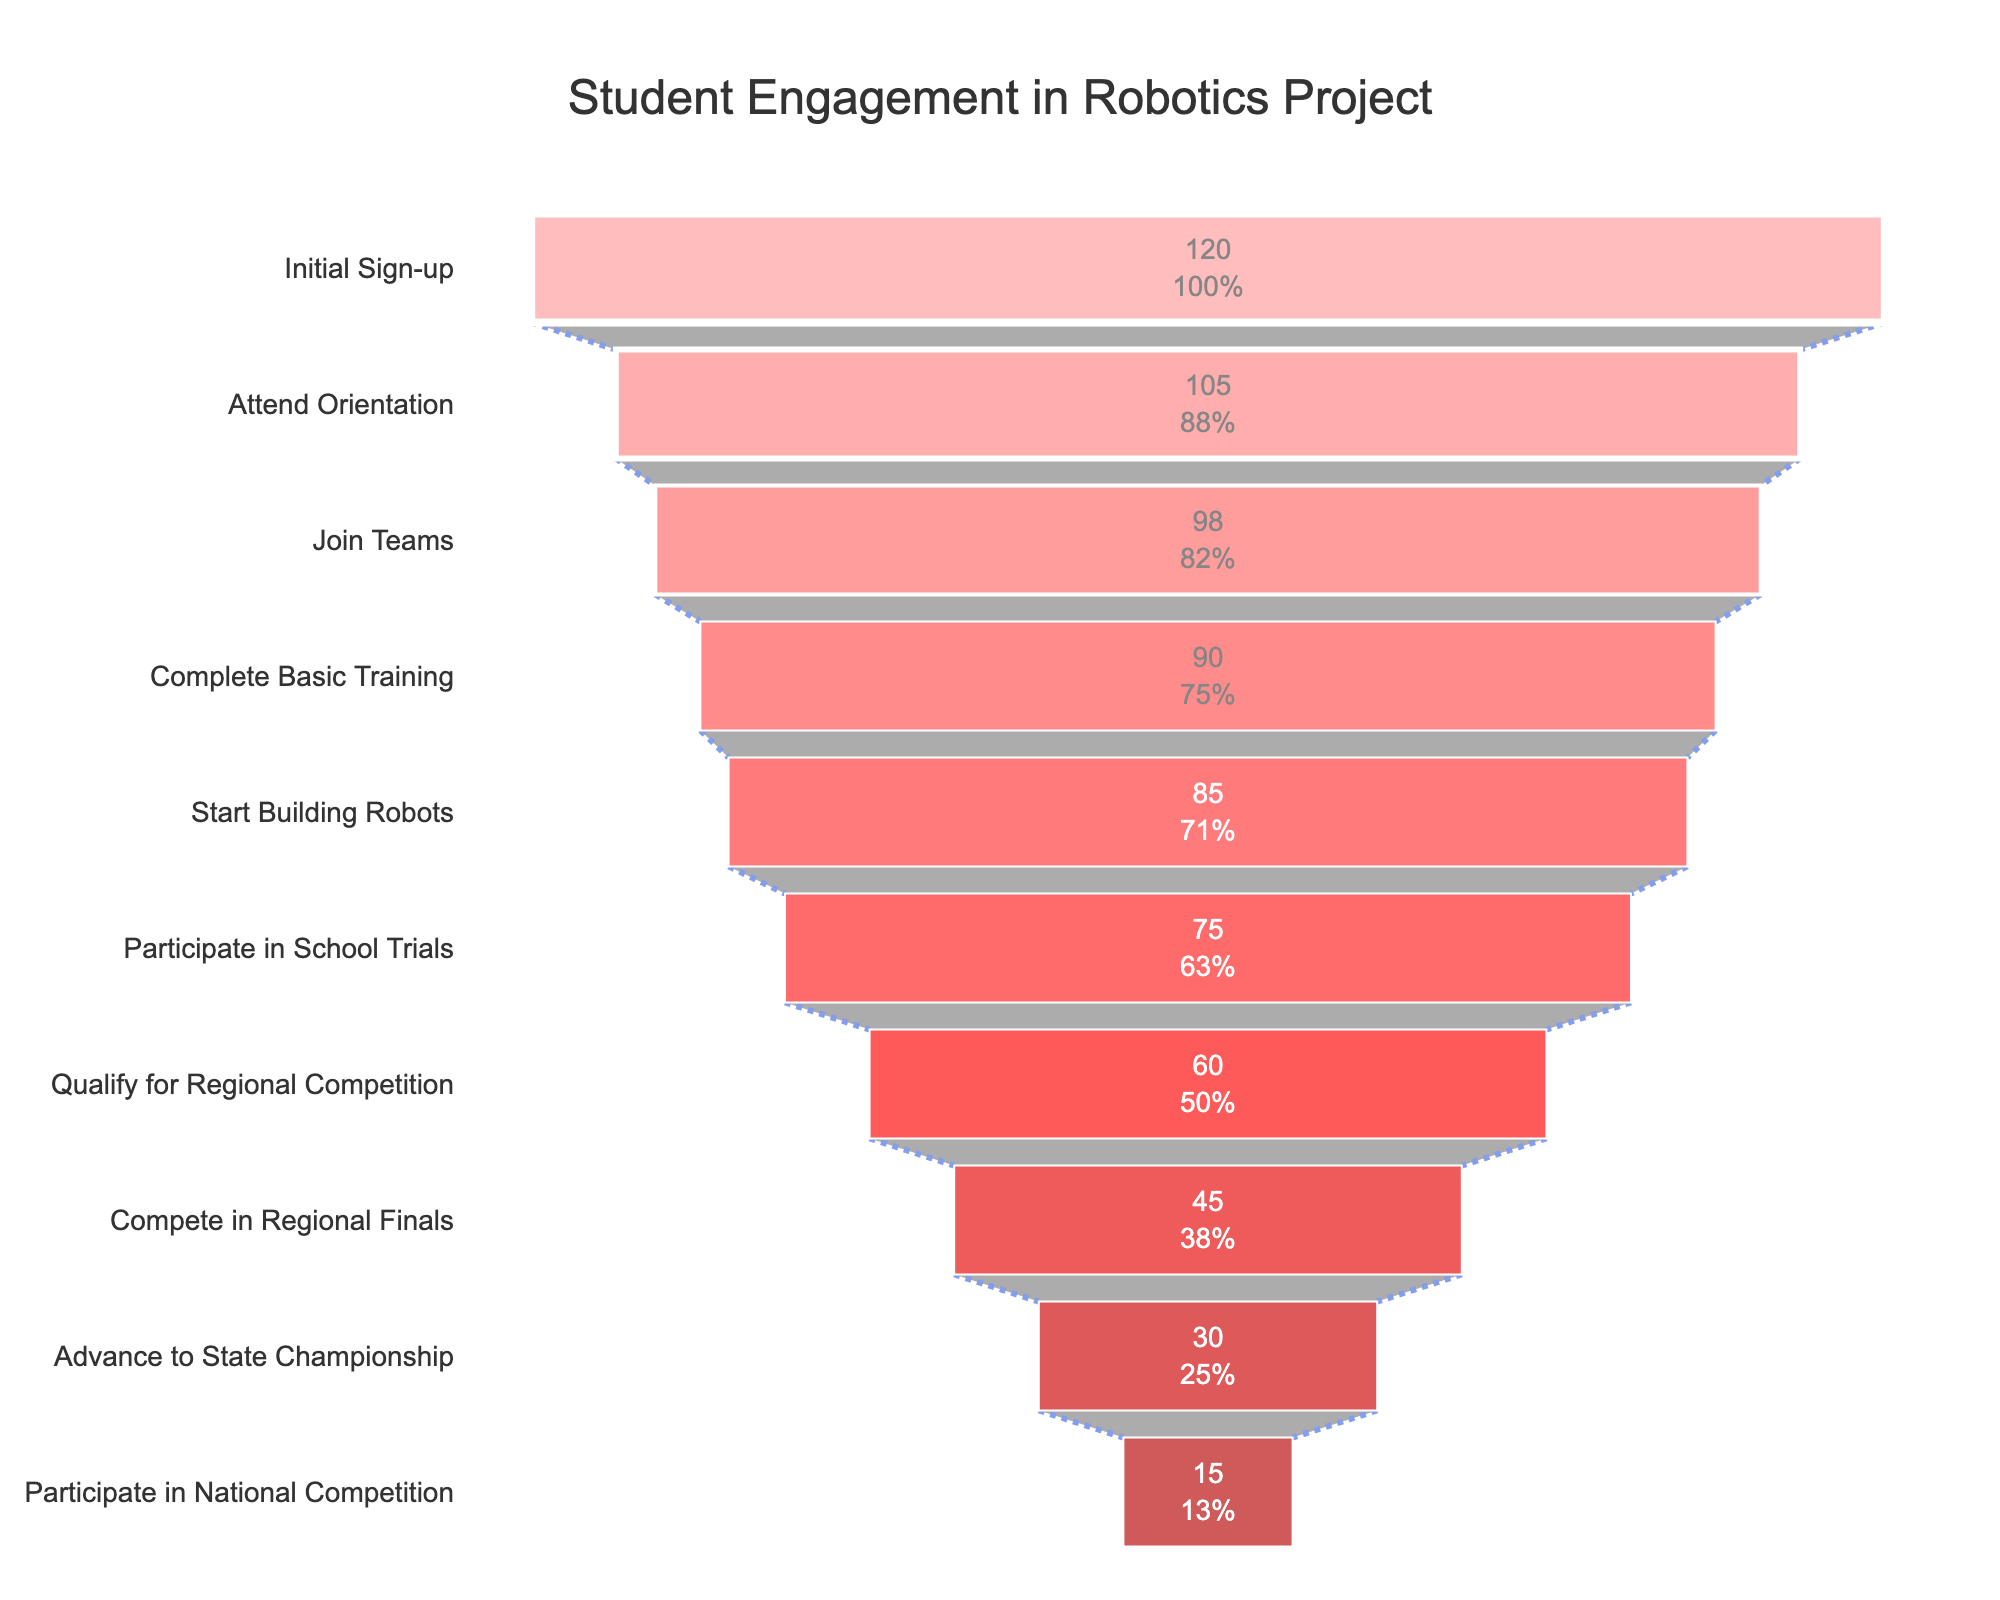What's the title of the chart? The title is displayed prominently at the top of the chart. Here, it reads "Student Engagement in Robotics Project."
Answer: Student Engagement in Robotics Project How many students participated in the school trials? Looking at the corresponding stage "Participate in School Trials" on the y-axis, the number next to it is 75.
Answer: 75 What's the percentage decrease in the number of students from the Initial Sign-up to the National Competition? The Initial Sign-up has 120 students, and the National Competition has 15 students. The percentage decrease is calculated as ((120 - 15) / 120) * 100. This gives a decrease of 87.5%.
Answer: 87.5% At which stage do you see the biggest drop in the number of students? The largest drop can be identified by scanning through the stages and finding the largest difference. From "Qualify for Regional Competition" (60) to "Compete in Regional Finals" (45) is the largest drop, with a decrease of 15 students.
Answer: Between Qualify for Regional Competition and Compete in Regional Finals, dropping by 15 students Is there any stage where more than 90% of the initial students are still participating? To check this, we need to see if any stage has more than 108 (which is 90% of 120) students. The "Automatic Telemetry Integration of Mainframe" stage has 105 students, so the answer is yes.
Answer: Yes, Attend Orientation stage How many students dropped out between the "Complete Basic Training" and "Start Building Robots" stages? The number of students in the "Complete Basic Training" stage is 90, and in the "Start Building Robots" stage, it is 85. Thus, the drop is 90 - 85 = 5 students.
Answer: 5 What color represents the furthest stage reached by the students, and what is it? The color for each stage gets progressively darker red, with the darkest red representing the final stage. The furthest stage reached is "Participate in National Competition," represented by a dark red color.
Answer: Dark red, Participate in National Competition How many stages are represented in the funnel chart? Count from the beginning to the end of the funnel, including all stages listed on the y-axis. There are 10 stages.
Answer: 10 What stage has the smallest number of students? The stage with the smallest number can be found at the bottom of the funnel. "Participate in National Competition" has the smallest number, with 15 students.
Answer: Participate in National Competition What's the difference in the number of students between the "Initial Sign-up" stage and the "Qualify for Regional Competition" stage? Subtract the number of students at the "Qualify for Regional Competition" stage from the "Initial Sign-up" stage. It is 120 - 60 = 60 students.
Answer: 60 